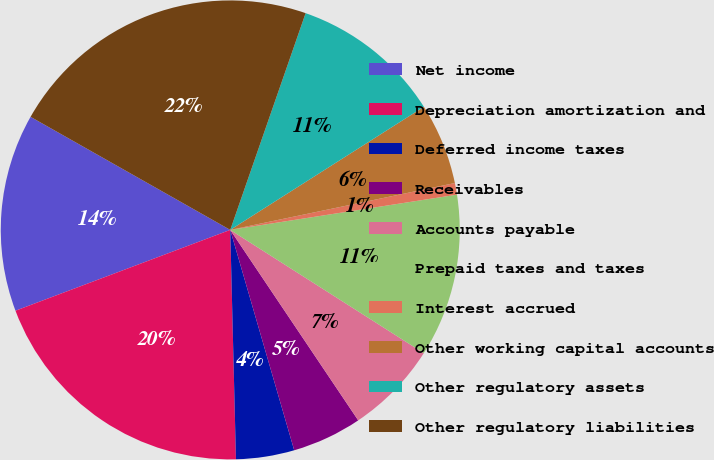Convert chart to OTSL. <chart><loc_0><loc_0><loc_500><loc_500><pie_chart><fcel>Net income<fcel>Depreciation amortization and<fcel>Deferred income taxes<fcel>Receivables<fcel>Accounts payable<fcel>Prepaid taxes and taxes<fcel>Interest accrued<fcel>Other working capital accounts<fcel>Other regulatory assets<fcel>Other regulatory liabilities<nl><fcel>13.93%<fcel>19.67%<fcel>4.1%<fcel>4.92%<fcel>6.56%<fcel>11.48%<fcel>0.82%<fcel>5.74%<fcel>10.66%<fcel>22.13%<nl></chart> 